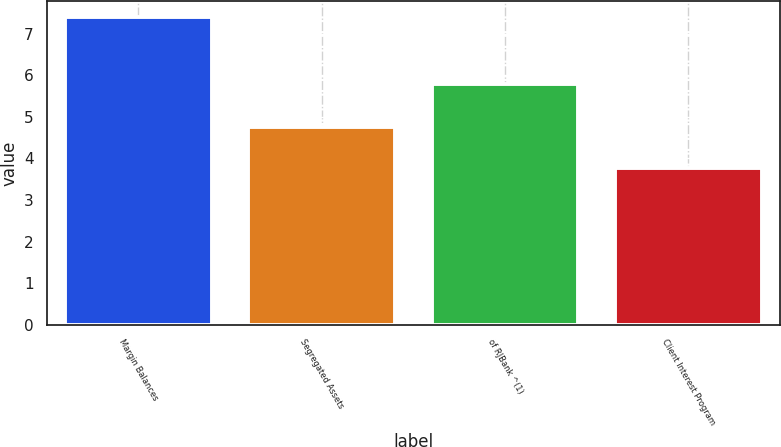<chart> <loc_0><loc_0><loc_500><loc_500><bar_chart><fcel>Margin Balances<fcel>Segregated Assets<fcel>of RJBank ^(1)<fcel>Client Interest Program<nl><fcel>7.42<fcel>4.75<fcel>5.8<fcel>3.78<nl></chart> 